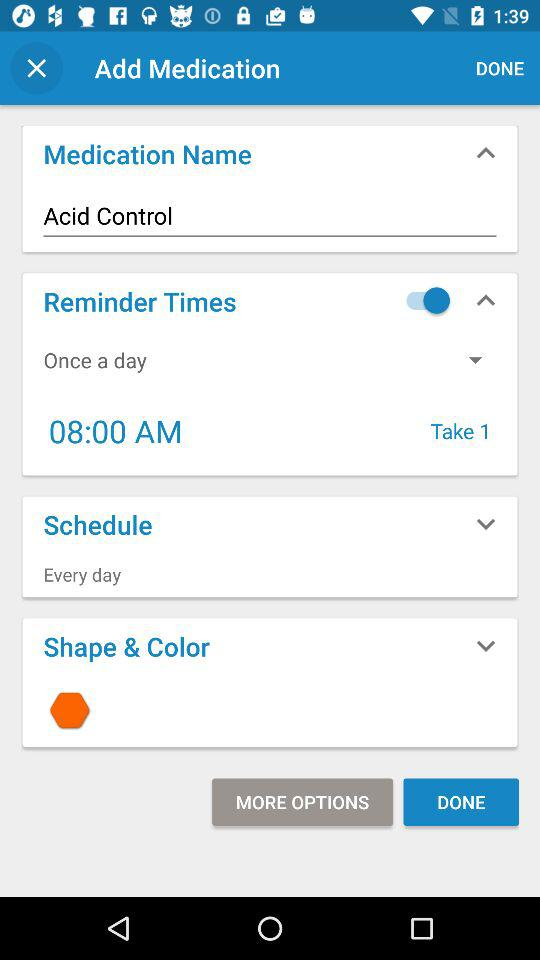What is the quantity of medicine to be taken daily? The quantity is 1. 